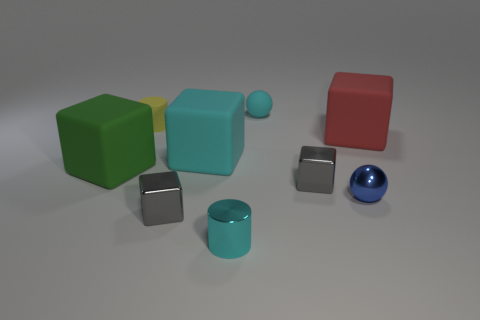What is the size of the green block that is made of the same material as the big red thing?
Your answer should be compact. Large. There is a blue metal sphere; is it the same size as the gray metal block in front of the blue thing?
Make the answer very short. Yes. What material is the object behind the yellow rubber object?
Your answer should be very brief. Rubber. There is a small cyan object behind the big green block; what number of tiny gray cubes are to the right of it?
Give a very brief answer. 1. Is there a big cyan matte thing that has the same shape as the tiny cyan matte object?
Keep it short and to the point. No. There is a cyan object that is behind the red thing; is it the same size as the cube on the right side of the blue shiny thing?
Your answer should be compact. No. What is the shape of the small cyan object in front of the small cylinder behind the cyan shiny cylinder?
Keep it short and to the point. Cylinder. How many other red rubber blocks have the same size as the red block?
Ensure brevity in your answer.  0. Are any large red rubber objects visible?
Ensure brevity in your answer.  Yes. Is there anything else that has the same color as the small metallic ball?
Make the answer very short. No. 